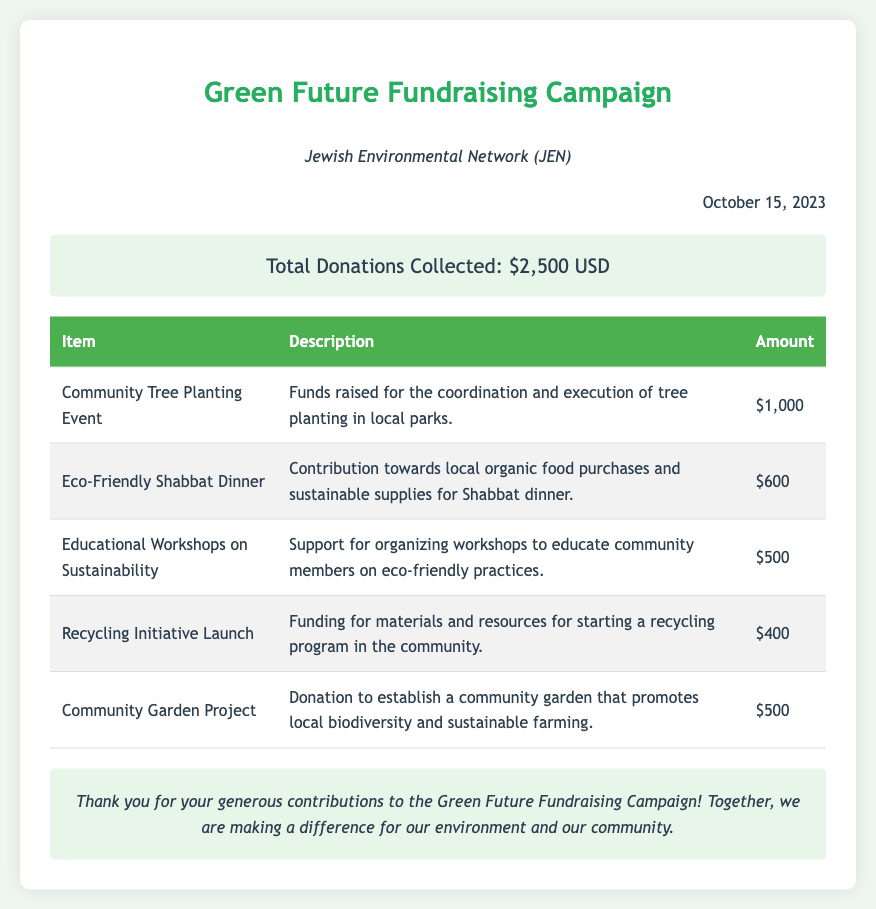What is the name of the fundraising campaign? The name of the fundraising campaign is mentioned in the title of the document.
Answer: Green Future Fundraising Campaign What is the total amount of donations collected? The total amount is clearly stated in the "total donations" section.
Answer: $2,500 USD Who organized the fundraising campaign? The organizing body is identified in the document's organization information.
Answer: Jewish Environmental Network (JEN) What event raised $1,000? The specific event that raised this amount can be found in the itemized donation table.
Answer: Community Tree Planting Event How much was contributed for the Eco-Friendly Shabbat Dinner? This amount is shown in the table under the respective item.
Answer: $600 What is the purpose of the Recycling Initiative Launch? The purpose is described in the table next to the respective item.
Answer: Starting a recycling program How many workshops on sustainability were supported? The total amount allocated to these workshops is indicated.
Answer: $500 What date was the bill issued? The date is noted in the document after the organization information.
Answer: October 15, 2023 What background color is used for the total donation section? The background color is described in the styles used in the document.
Answer: Light green 